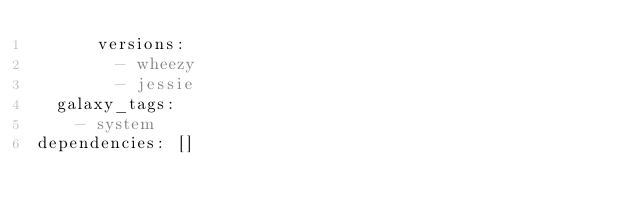Convert code to text. <code><loc_0><loc_0><loc_500><loc_500><_YAML_>      versions:
        - wheezy
        - jessie
  galaxy_tags:
    - system
dependencies: []
</code> 